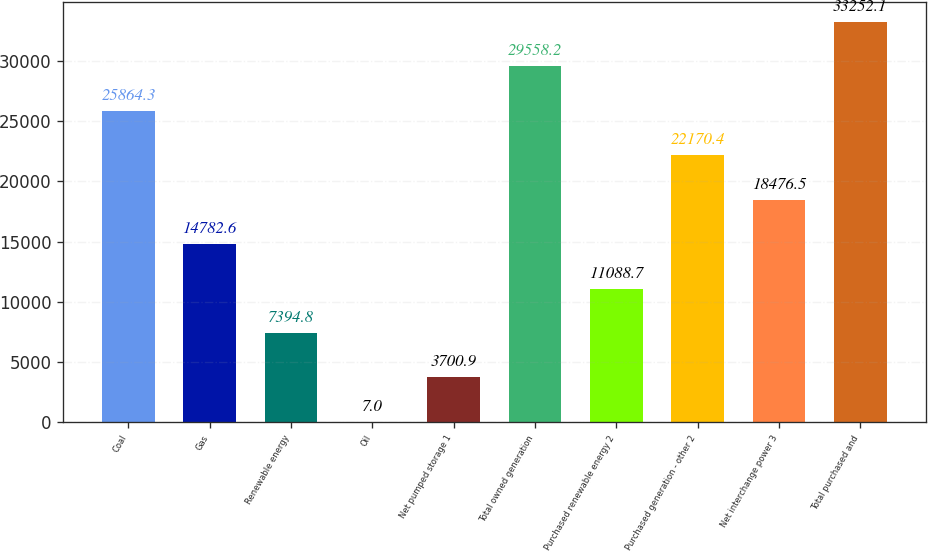Convert chart to OTSL. <chart><loc_0><loc_0><loc_500><loc_500><bar_chart><fcel>Coal<fcel>Gas<fcel>Renewable energy<fcel>Oil<fcel>Net pumped storage 1<fcel>Total owned generation<fcel>Purchased renewable energy 2<fcel>Purchased generation - other 2<fcel>Net interchange power 3<fcel>Total purchased and<nl><fcel>25864.3<fcel>14782.6<fcel>7394.8<fcel>7<fcel>3700.9<fcel>29558.2<fcel>11088.7<fcel>22170.4<fcel>18476.5<fcel>33252.1<nl></chart> 